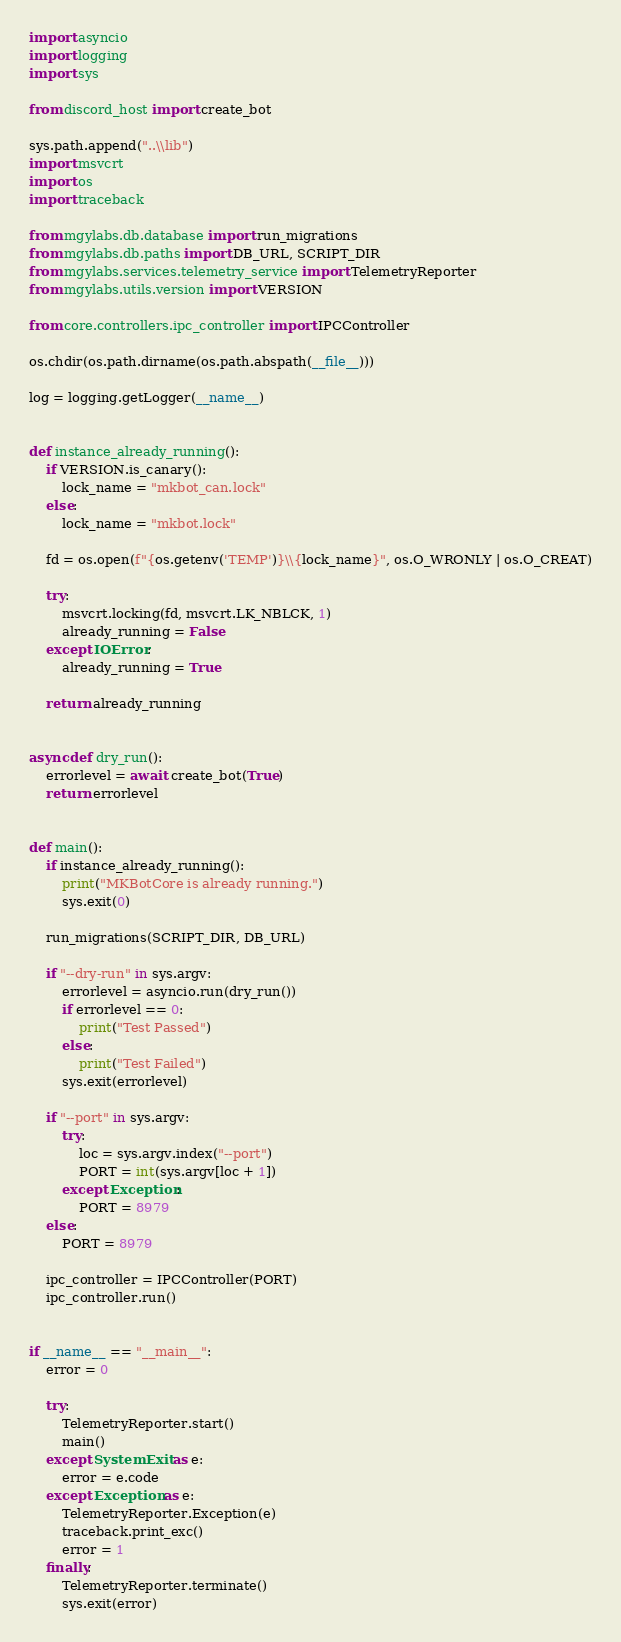<code> <loc_0><loc_0><loc_500><loc_500><_Python_>import asyncio
import logging
import sys

from discord_host import create_bot

sys.path.append("..\\lib")
import msvcrt
import os
import traceback

from mgylabs.db.database import run_migrations
from mgylabs.db.paths import DB_URL, SCRIPT_DIR
from mgylabs.services.telemetry_service import TelemetryReporter
from mgylabs.utils.version import VERSION

from core.controllers.ipc_controller import IPCController

os.chdir(os.path.dirname(os.path.abspath(__file__)))

log = logging.getLogger(__name__)


def instance_already_running():
    if VERSION.is_canary():
        lock_name = "mkbot_can.lock"
    else:
        lock_name = "mkbot.lock"

    fd = os.open(f"{os.getenv('TEMP')}\\{lock_name}", os.O_WRONLY | os.O_CREAT)

    try:
        msvcrt.locking(fd, msvcrt.LK_NBLCK, 1)
        already_running = False
    except IOError:
        already_running = True

    return already_running


async def dry_run():
    errorlevel = await create_bot(True)
    return errorlevel


def main():
    if instance_already_running():
        print("MKBotCore is already running.")
        sys.exit(0)

    run_migrations(SCRIPT_DIR, DB_URL)

    if "--dry-run" in sys.argv:
        errorlevel = asyncio.run(dry_run())
        if errorlevel == 0:
            print("Test Passed")
        else:
            print("Test Failed")
        sys.exit(errorlevel)

    if "--port" in sys.argv:
        try:
            loc = sys.argv.index("--port")
            PORT = int(sys.argv[loc + 1])
        except Exception:
            PORT = 8979
    else:
        PORT = 8979

    ipc_controller = IPCController(PORT)
    ipc_controller.run()


if __name__ == "__main__":
    error = 0

    try:
        TelemetryReporter.start()
        main()
    except SystemExit as e:
        error = e.code
    except Exception as e:
        TelemetryReporter.Exception(e)
        traceback.print_exc()
        error = 1
    finally:
        TelemetryReporter.terminate()
        sys.exit(error)
</code> 